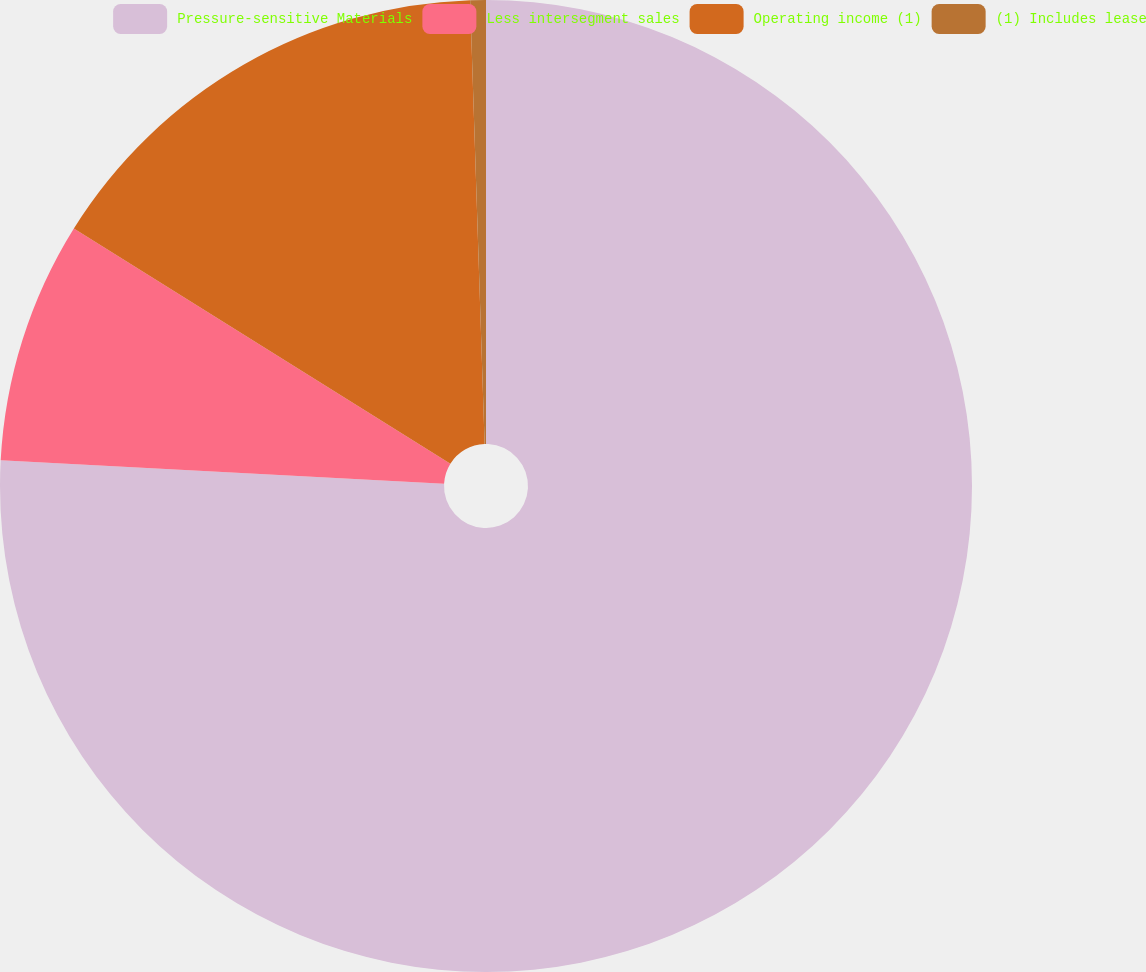Convert chart to OTSL. <chart><loc_0><loc_0><loc_500><loc_500><pie_chart><fcel>Pressure-sensitive Materials<fcel>Less intersegment sales<fcel>Operating income (1)<fcel>(1) Includes lease<nl><fcel>75.84%<fcel>8.05%<fcel>15.59%<fcel>0.52%<nl></chart> 